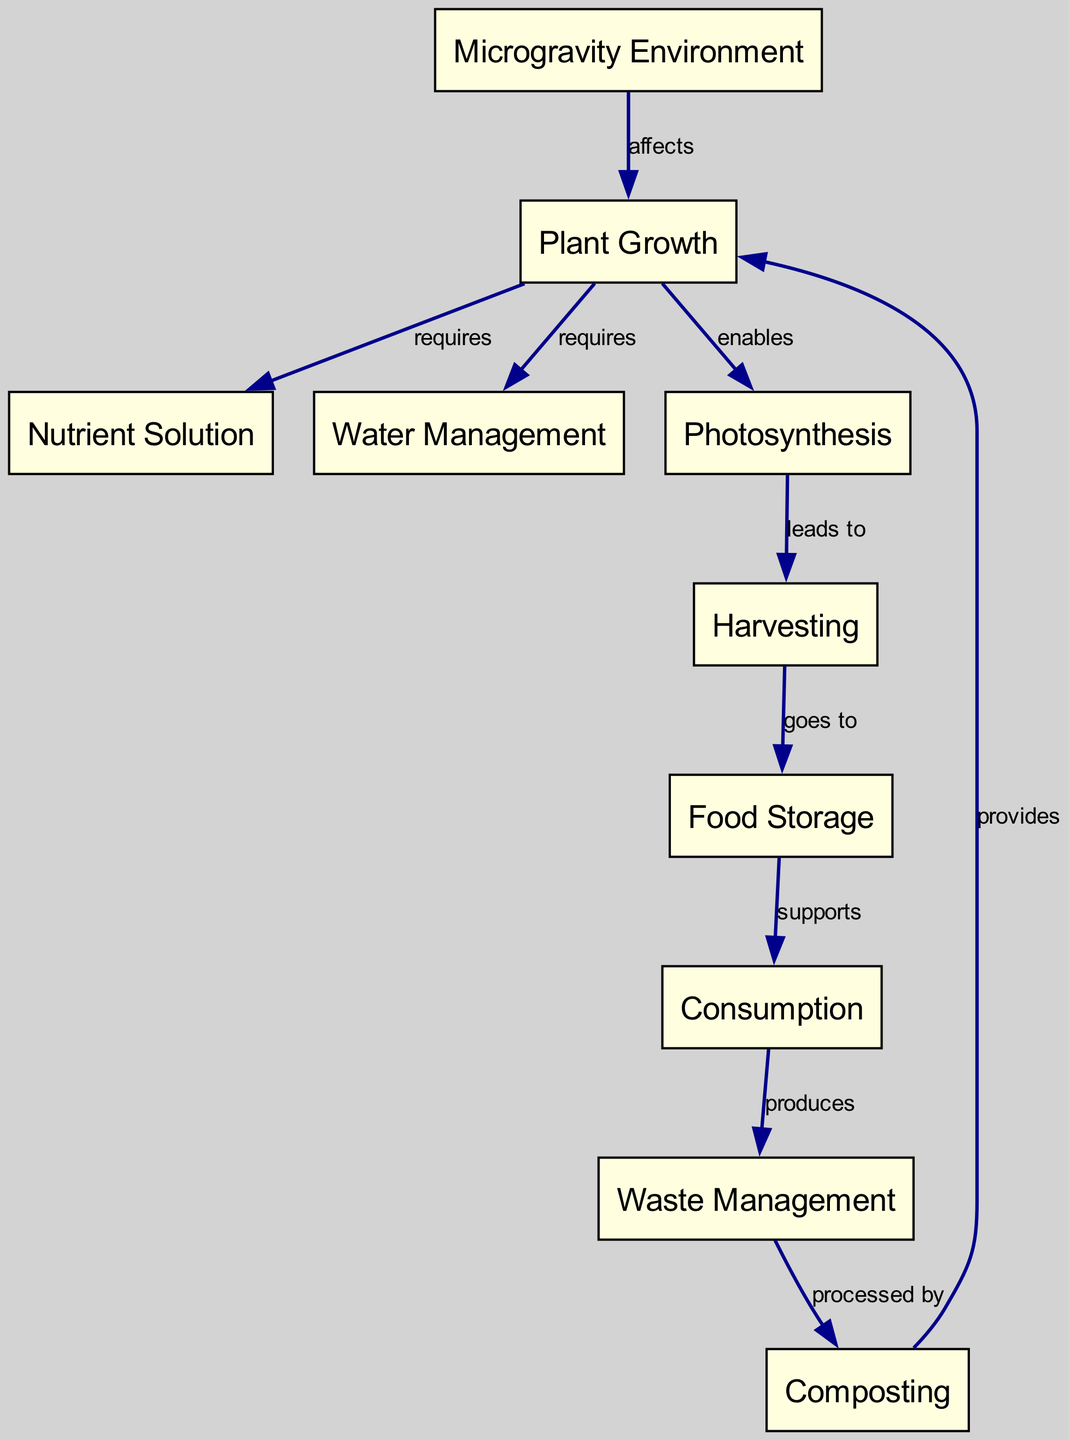What is the first node in the diagram? Referring to the arrangement of the nodes, the first node listed is "Microgravity Environment".
Answer: Microgravity Environment How many nodes are present in the diagram? Counting each node listed, there are 10 nodes in total.
Answer: 10 What is the relationship between "Plant Growth" and "Nutrient Solution"? "Plant Growth" requires "Nutrient Solution" as indicated by the directed edge from Plant Growth to Nutrient Solution labeled "requires".
Answer: requires Which node leads to "Harvesting"? The node "Photosynthesis" leads to "Harvesting", as shown by the directed edge labeled "leads to".
Answer: Photosynthesis What does "Consumption" produce? "Consumption" produces "Waste Management" as indicated by the directed edge labeled "produces".
Answer: Waste Management What provides essential nutrients for "Plant Growth"? "Nutrient Solution" provides essential nutrients, as it is a requirement for "Plant Growth".
Answer: Nutrient Solution Which two processes are linked through "Water Management"? "Plant Growth" and "Water Management" are linked, with "Plant Growth" requiring "Water Management" for hydration.
Answer: Plant Growth and Water Management How does composting interact with food waste in the chain? "Composting" processes "Waste Management", which demonstrates the recycling aspect of the waste management process leading back to "Plant Growth".
Answer: processed by What supports "Consumption"? "Food Storage" supports "Consumption", as illustrated by the directed edge labeled "supports".
Answer: Food Storage Which node affects "Plant Growth"? "Microgravity Environment" affects "Plant Growth" as indicated by the edge labeled "affects".
Answer: Microgravity Environment 